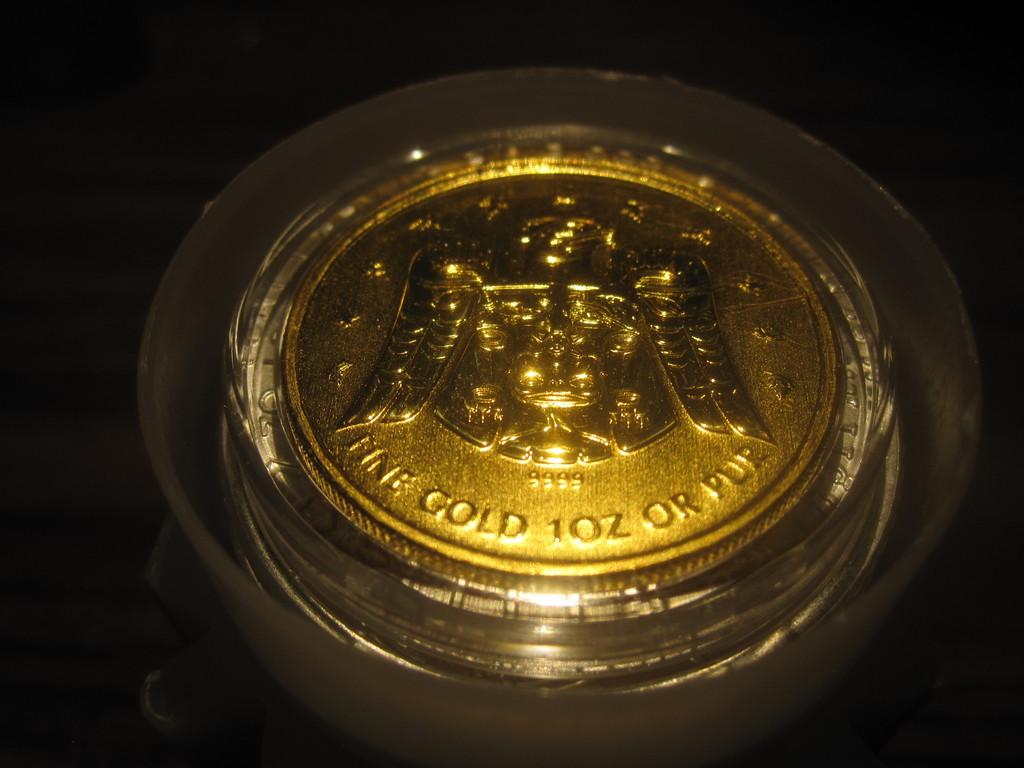<image>
Describe the image concisely. Golden coin that says "Fine Gold 1oz or Pur". 